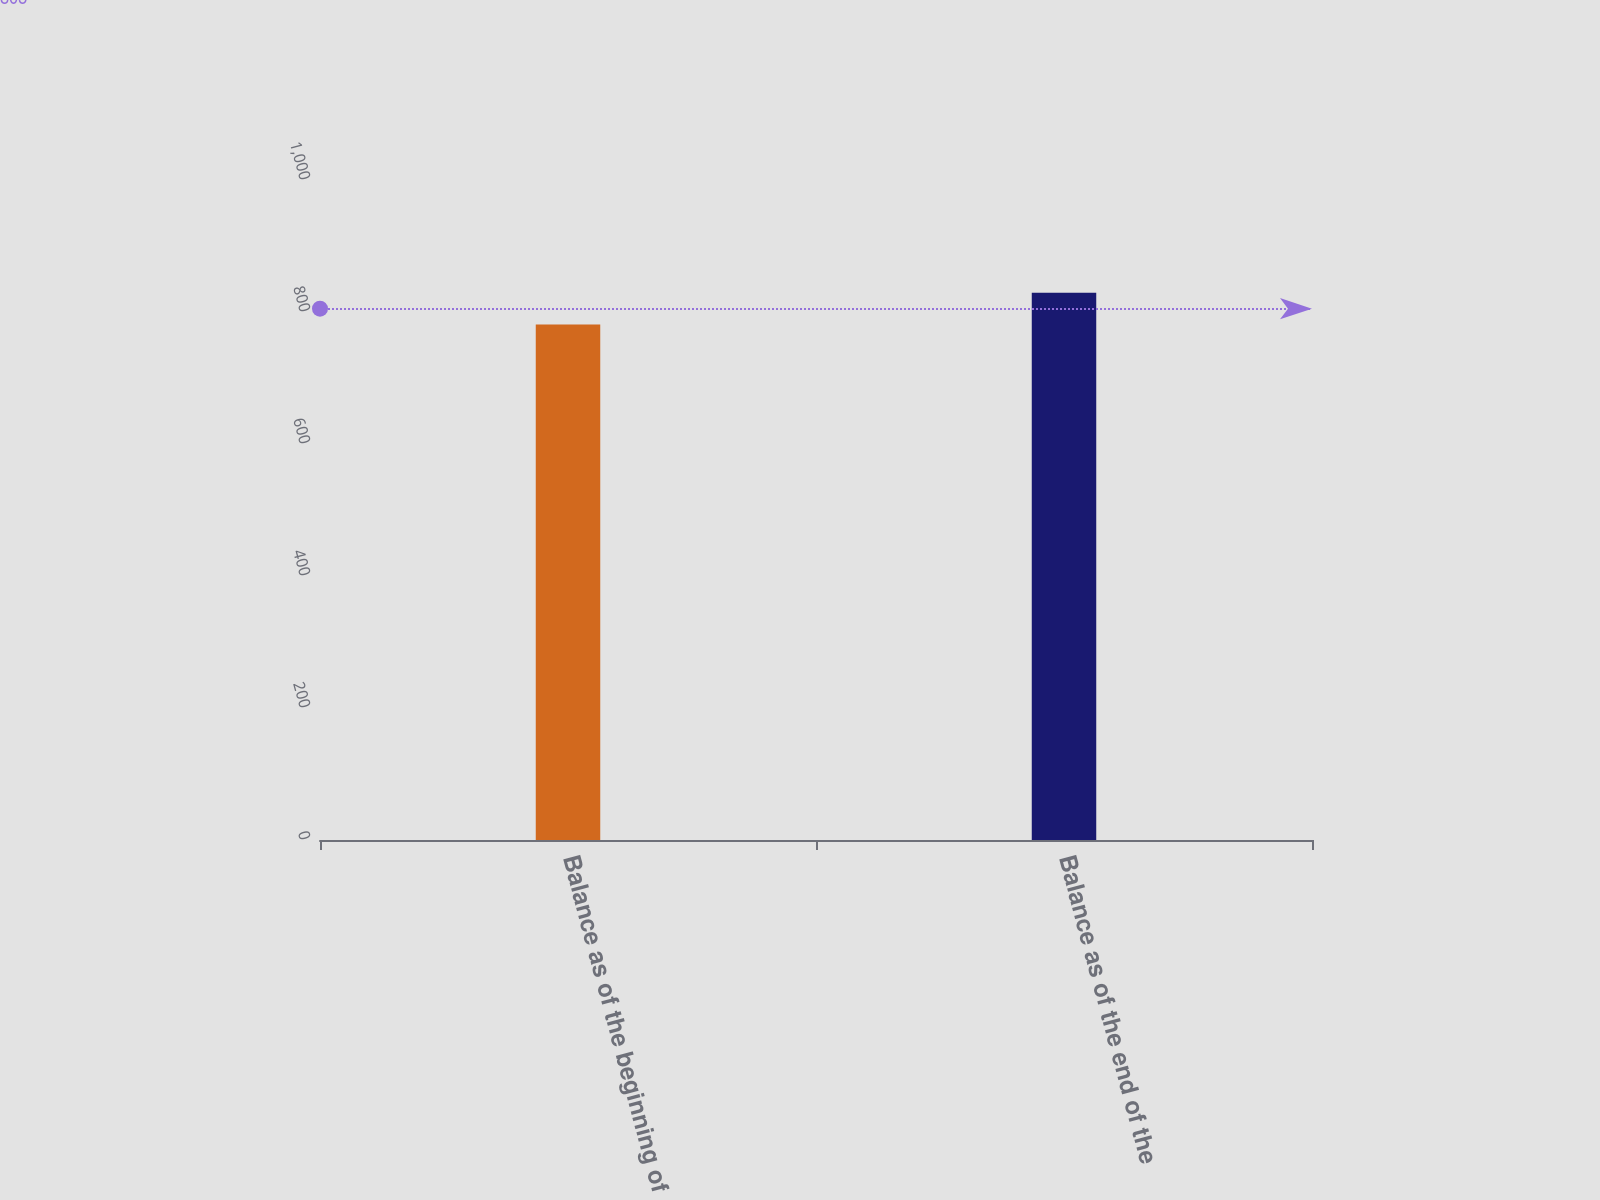<chart> <loc_0><loc_0><loc_500><loc_500><bar_chart><fcel>Balance as of the beginning of<fcel>Balance as of the end of the<nl><fcel>781<fcel>829<nl></chart> 